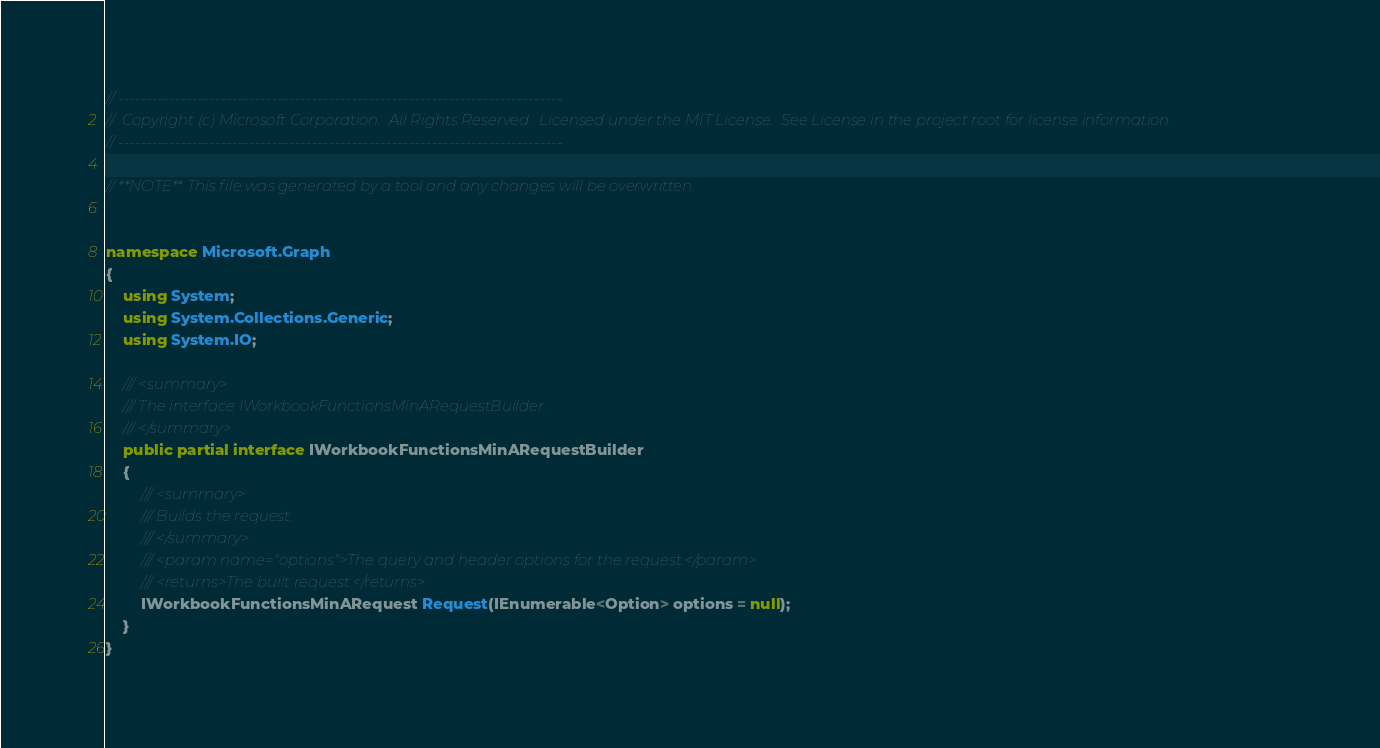<code> <loc_0><loc_0><loc_500><loc_500><_C#_>// ------------------------------------------------------------------------------
//  Copyright (c) Microsoft Corporation.  All Rights Reserved.  Licensed under the MIT License.  See License in the project root for license information.
// ------------------------------------------------------------------------------

// **NOTE** This file was generated by a tool and any changes will be overwritten.


namespace Microsoft.Graph
{
    using System;
    using System.Collections.Generic;
    using System.IO;

    /// <summary>
    /// The interface IWorkbookFunctionsMinARequestBuilder.
    /// </summary>
    public partial interface IWorkbookFunctionsMinARequestBuilder
    {
        /// <summary>
        /// Builds the request.
        /// </summary>
        /// <param name="options">The query and header options for the request.</param>
        /// <returns>The built request.</returns>
        IWorkbookFunctionsMinARequest Request(IEnumerable<Option> options = null);
    }
}
</code> 